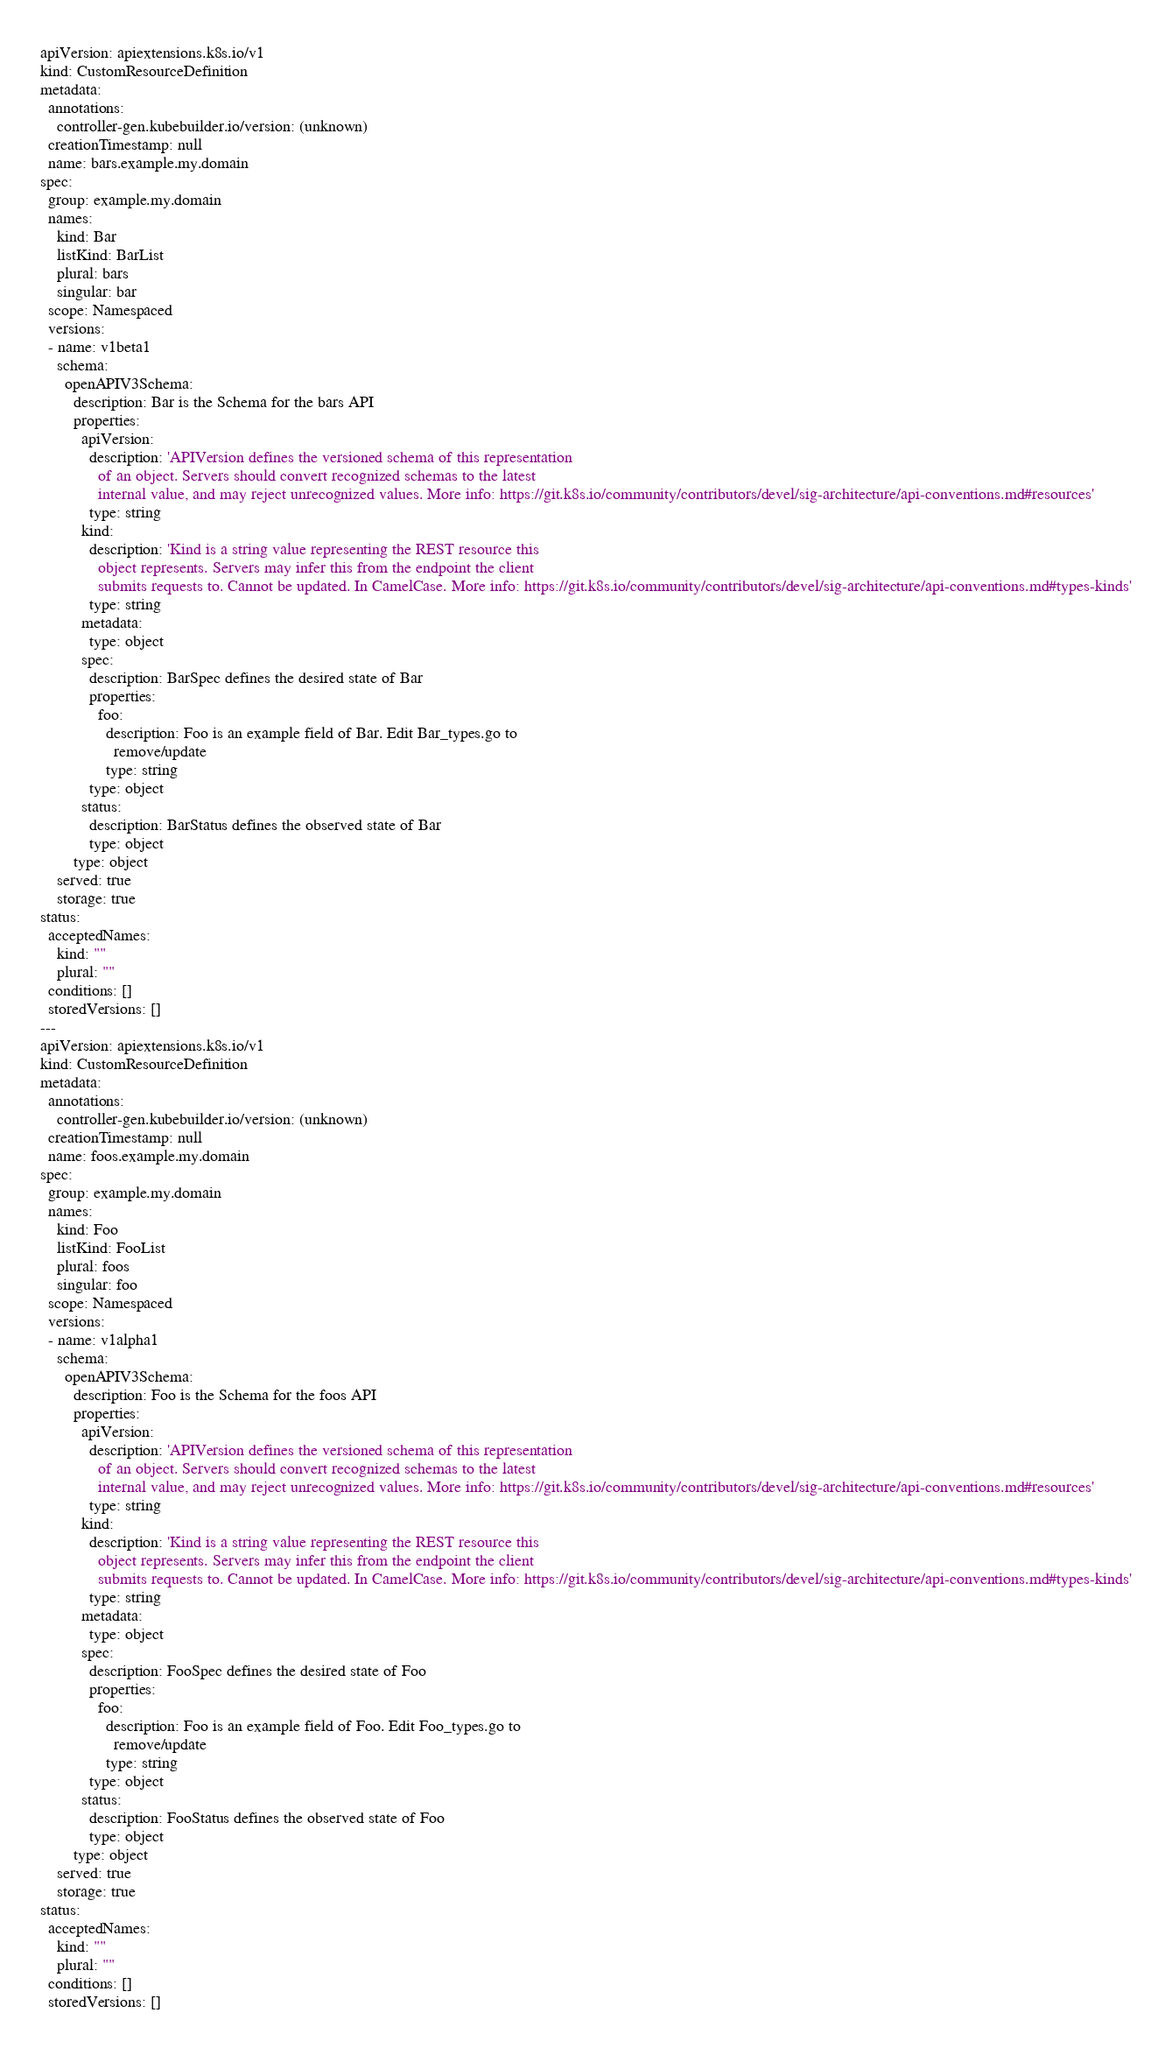Convert code to text. <code><loc_0><loc_0><loc_500><loc_500><_YAML_>apiVersion: apiextensions.k8s.io/v1
kind: CustomResourceDefinition
metadata:
  annotations:
    controller-gen.kubebuilder.io/version: (unknown)
  creationTimestamp: null
  name: bars.example.my.domain
spec:
  group: example.my.domain
  names:
    kind: Bar
    listKind: BarList
    plural: bars
    singular: bar
  scope: Namespaced
  versions:
  - name: v1beta1
    schema:
      openAPIV3Schema:
        description: Bar is the Schema for the bars API
        properties:
          apiVersion:
            description: 'APIVersion defines the versioned schema of this representation
              of an object. Servers should convert recognized schemas to the latest
              internal value, and may reject unrecognized values. More info: https://git.k8s.io/community/contributors/devel/sig-architecture/api-conventions.md#resources'
            type: string
          kind:
            description: 'Kind is a string value representing the REST resource this
              object represents. Servers may infer this from the endpoint the client
              submits requests to. Cannot be updated. In CamelCase. More info: https://git.k8s.io/community/contributors/devel/sig-architecture/api-conventions.md#types-kinds'
            type: string
          metadata:
            type: object
          spec:
            description: BarSpec defines the desired state of Bar
            properties:
              foo:
                description: Foo is an example field of Bar. Edit Bar_types.go to
                  remove/update
                type: string
            type: object
          status:
            description: BarStatus defines the observed state of Bar
            type: object
        type: object
    served: true
    storage: true
status:
  acceptedNames:
    kind: ""
    plural: ""
  conditions: []
  storedVersions: []
---
apiVersion: apiextensions.k8s.io/v1
kind: CustomResourceDefinition
metadata:
  annotations:
    controller-gen.kubebuilder.io/version: (unknown)
  creationTimestamp: null
  name: foos.example.my.domain
spec:
  group: example.my.domain
  names:
    kind: Foo
    listKind: FooList
    plural: foos
    singular: foo
  scope: Namespaced
  versions:
  - name: v1alpha1
    schema:
      openAPIV3Schema:
        description: Foo is the Schema for the foos API
        properties:
          apiVersion:
            description: 'APIVersion defines the versioned schema of this representation
              of an object. Servers should convert recognized schemas to the latest
              internal value, and may reject unrecognized values. More info: https://git.k8s.io/community/contributors/devel/sig-architecture/api-conventions.md#resources'
            type: string
          kind:
            description: 'Kind is a string value representing the REST resource this
              object represents. Servers may infer this from the endpoint the client
              submits requests to. Cannot be updated. In CamelCase. More info: https://git.k8s.io/community/contributors/devel/sig-architecture/api-conventions.md#types-kinds'
            type: string
          metadata:
            type: object
          spec:
            description: FooSpec defines the desired state of Foo
            properties:
              foo:
                description: Foo is an example field of Foo. Edit Foo_types.go to
                  remove/update
                type: string
            type: object
          status:
            description: FooStatus defines the observed state of Foo
            type: object
        type: object
    served: true
    storage: true
status:
  acceptedNames:
    kind: ""
    plural: ""
  conditions: []
  storedVersions: []
</code> 